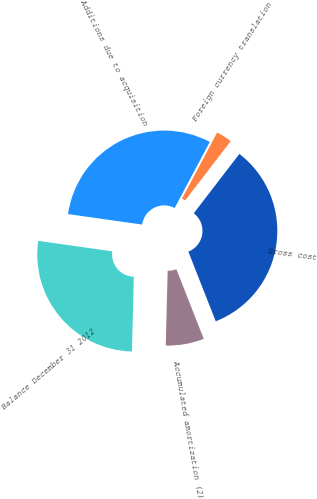Convert chart to OTSL. <chart><loc_0><loc_0><loc_500><loc_500><pie_chart><fcel>Additions due to acquisition<fcel>Foreign currency translation<fcel>Gross cost<fcel>Accumulated amortization (2)<fcel>Balance December 31 2012<nl><fcel>30.55%<fcel>2.64%<fcel>33.61%<fcel>6.36%<fcel>26.83%<nl></chart> 